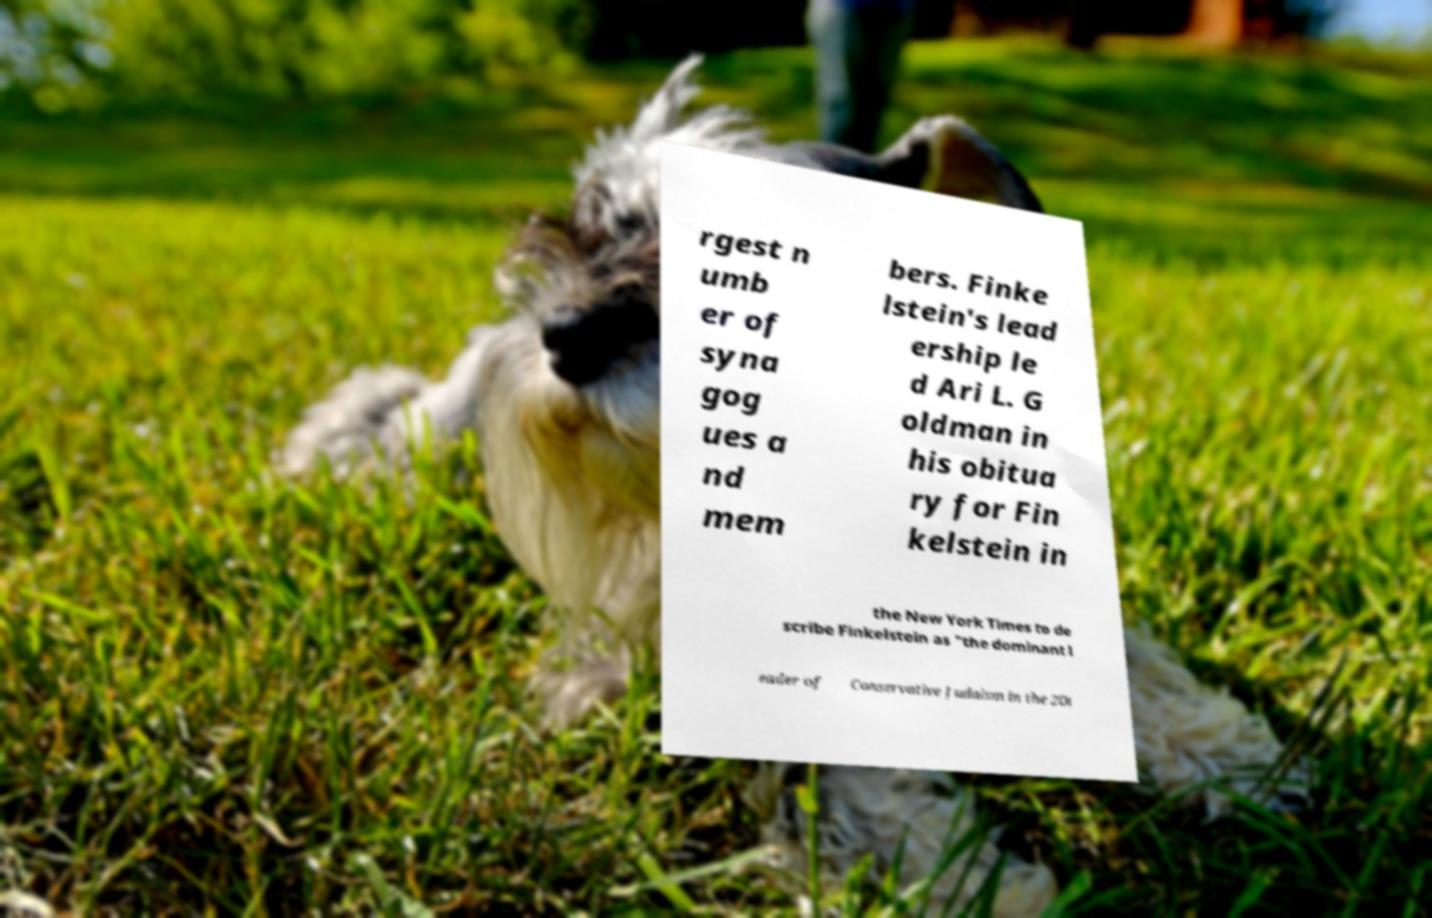I need the written content from this picture converted into text. Can you do that? rgest n umb er of syna gog ues a nd mem bers. Finke lstein's lead ership le d Ari L. G oldman in his obitua ry for Fin kelstein in the New York Times to de scribe Finkelstein as "the dominant l eader of Conservative Judaism in the 20t 